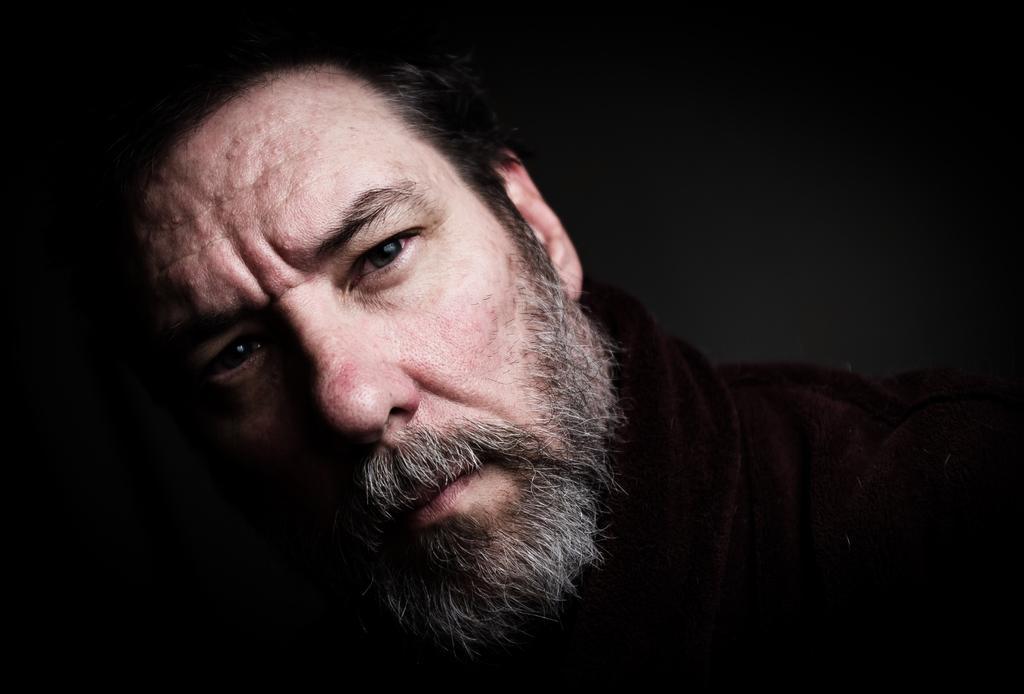Could you give a brief overview of what you see in this image? In this image I can see a person. In the image background is black in color. 